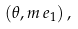Convert formula to latex. <formula><loc_0><loc_0><loc_500><loc_500>( \theta , m \, e _ { 1 } ) \, ,</formula> 